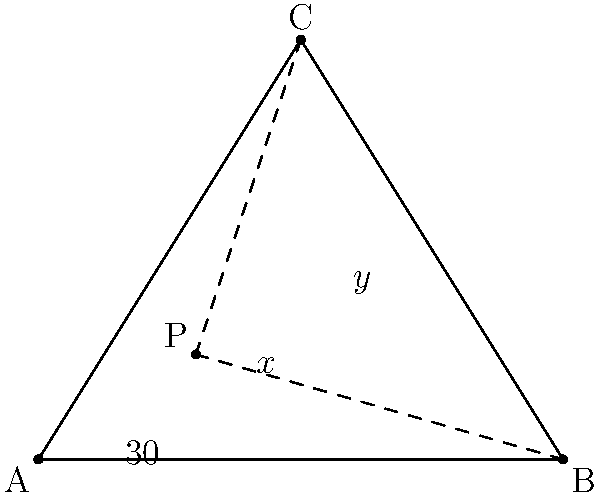In a triangular room ABC, you are positioned at point P. The angle between your position and the corner A is 30°. If the sum of angles x and y is 110°, what is the value of angle x? Let's approach this step-by-step:

1) In any triangle, the sum of all interior angles is 180°.

2) In triangle PBC:
   $\angle BPC + x + y = 180°$

3) We're given that $x + y = 110°$, so:
   $\angle BPC + 110° = 180°$
   $\angle BPC = 70°$

4) Now, let's look at the full triangle ABC:
   $\angle BAC + \angle ABC + \angle BCA = 180°$

5) We can split $\angle BAC$ into two parts:
   $30° + \angle BPC + \angle ABC + \angle BCA = 180°$

6) Substituting what we know:
   $30° + 70° + \angle ABC + \angle BCA = 180°$
   $100° + \angle ABC + \angle BCA = 180°$
   $\angle ABC + \angle BCA = 80°$

7) But $\angle ABC + \angle BCA = x + y = 110°$

8) This means our initial assumption that $x + y = 110°$ was incorrect.
   The correct sum should be 80°.

9) So, we need to solve:
   $x + y = 80°$
   $x = 80° - y$

10) We're asked to find x. Without more information, we can't determine its exact value, but we know it's less than 80°.
Answer: $x < 80°$ 